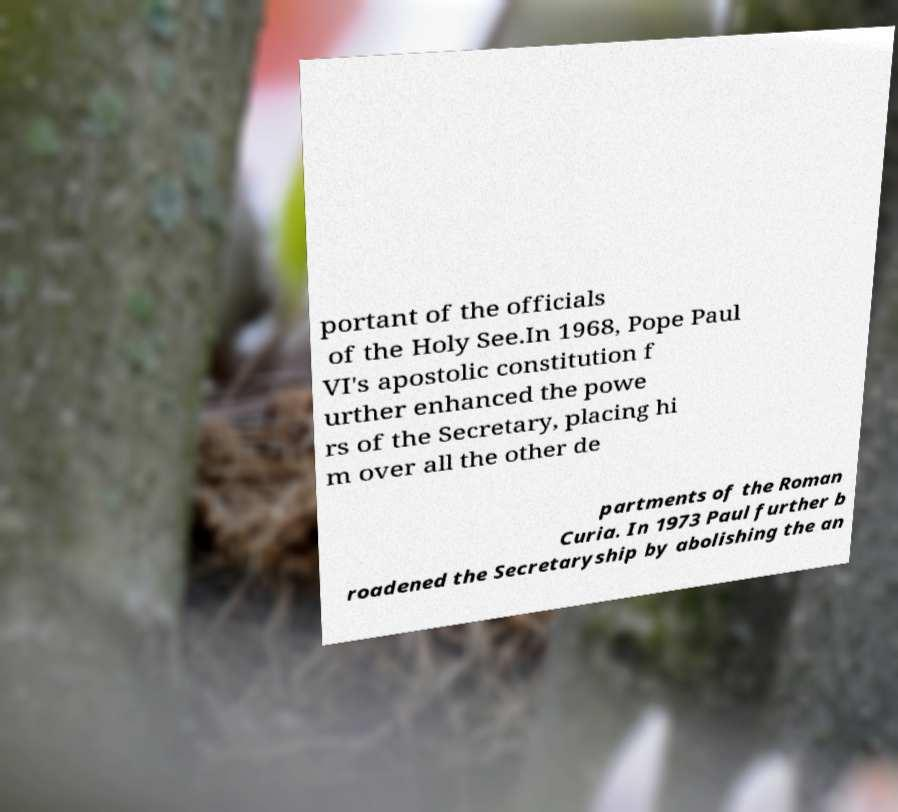Please identify and transcribe the text found in this image. portant of the officials of the Holy See.In 1968, Pope Paul VI's apostolic constitution f urther enhanced the powe rs of the Secretary, placing hi m over all the other de partments of the Roman Curia. In 1973 Paul further b roadened the Secretaryship by abolishing the an 